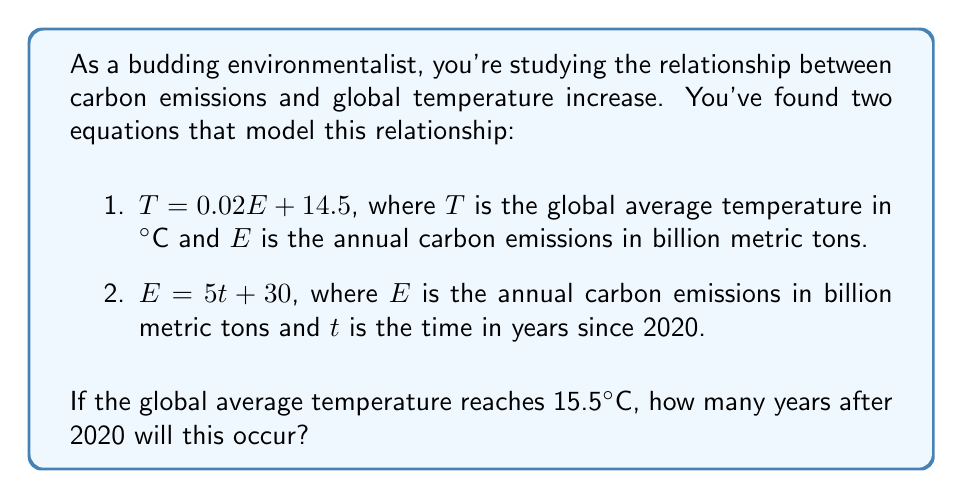Give your solution to this math problem. Let's approach this step-by-step:

1) We have two equations:
   $T = 0.02E + 14.5$ (Temperature equation)
   $E = 5t + 30$ (Emissions equation)

2) We want to find when $T = 15.5°C$. Let's substitute this into the temperature equation:

   $15.5 = 0.02E + 14.5$

3) Solve this equation for $E$:
   $15.5 - 14.5 = 0.02E$
   $1 = 0.02E$
   $E = 1 / 0.02 = 50$

4) So, when the temperature reaches 15.5°C, the emissions will be 50 billion metric tons.

5) Now, let's use the emissions equation to find when $E = 50$:

   $50 = 5t + 30$

6) Solve this equation for $t$:
   $50 - 30 = 5t$
   $20 = 5t$
   $t = 20 / 5 = 4$

Therefore, the temperature will reach 15.5°C 4 years after 2020.
Answer: 4 years after 2020 